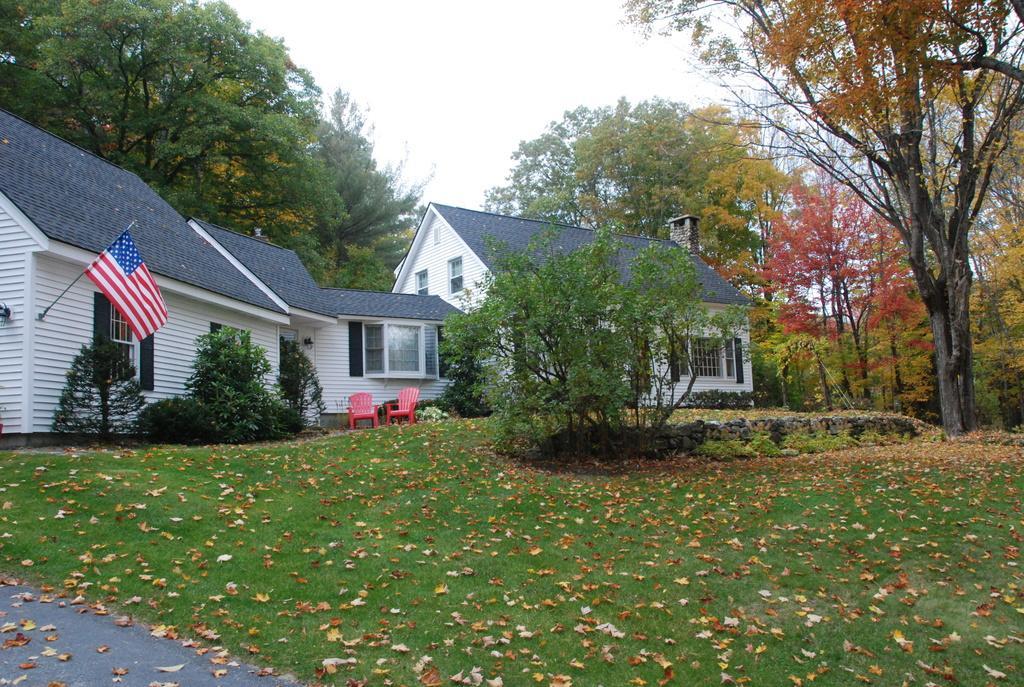In one or two sentences, can you explain what this image depicts? In this image we can see there are grasses everywhere on the ground and in the middle there are houses and on the right side there is a tree. 